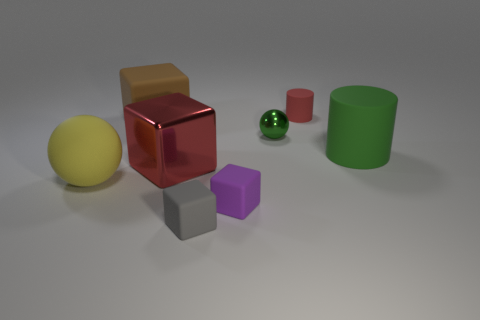Subtract all matte cubes. How many cubes are left? 1 Add 1 large metallic blocks. How many objects exist? 9 Subtract all purple cubes. How many cubes are left? 3 Subtract all cylinders. How many objects are left? 6 Subtract 2 cylinders. How many cylinders are left? 0 Subtract all green cubes. Subtract all yellow balls. How many cubes are left? 4 Subtract all large cyan matte spheres. Subtract all big green objects. How many objects are left? 7 Add 6 brown objects. How many brown objects are left? 7 Add 4 big green matte cylinders. How many big green matte cylinders exist? 5 Subtract 0 red balls. How many objects are left? 8 